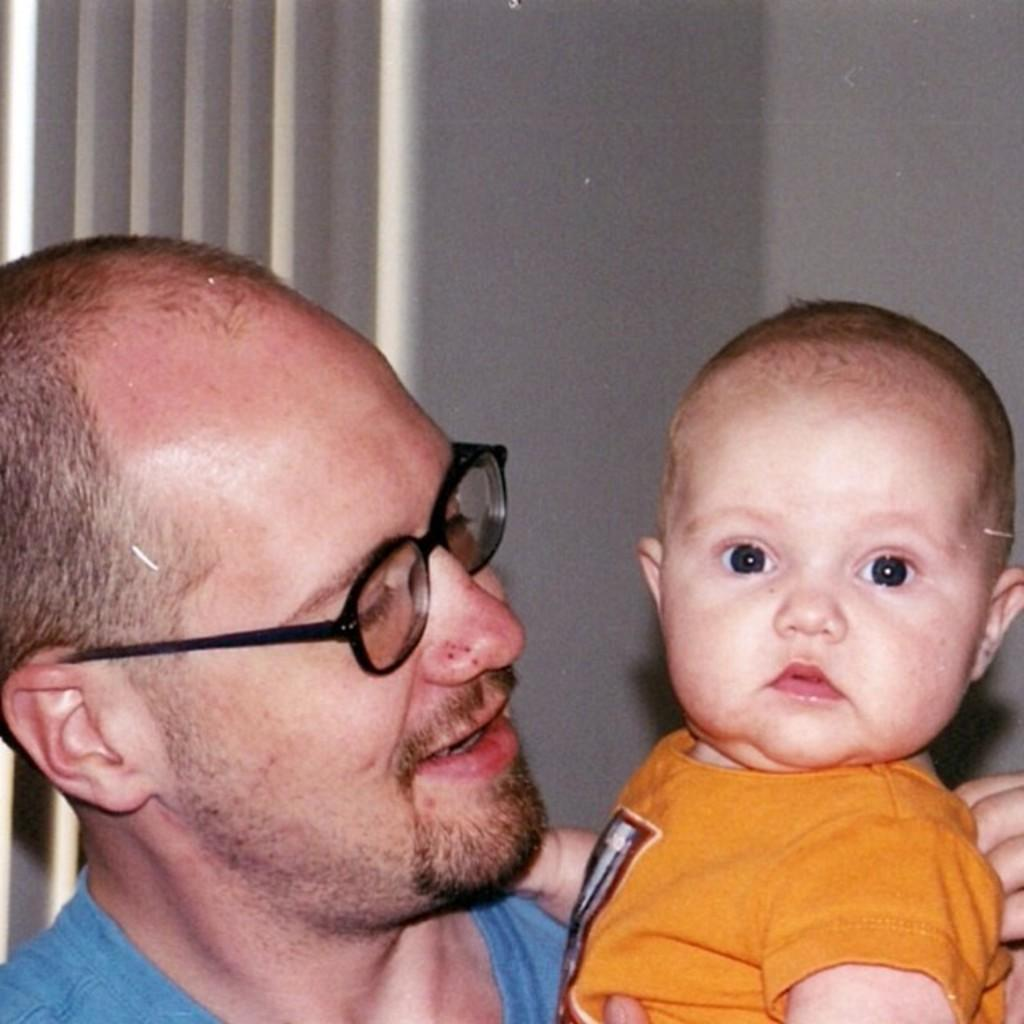How many people are in the image? There are two persons in the image. Where are the two persons located in relation to the image? The two persons are in front. What is visible behind the two persons? There is a wall behind the two persons. What type of tub can be seen in the image? There is no tub present in the image. Can you see any jellyfish swimming near the two persons in the image? There are no jellyfish visible in the image. 